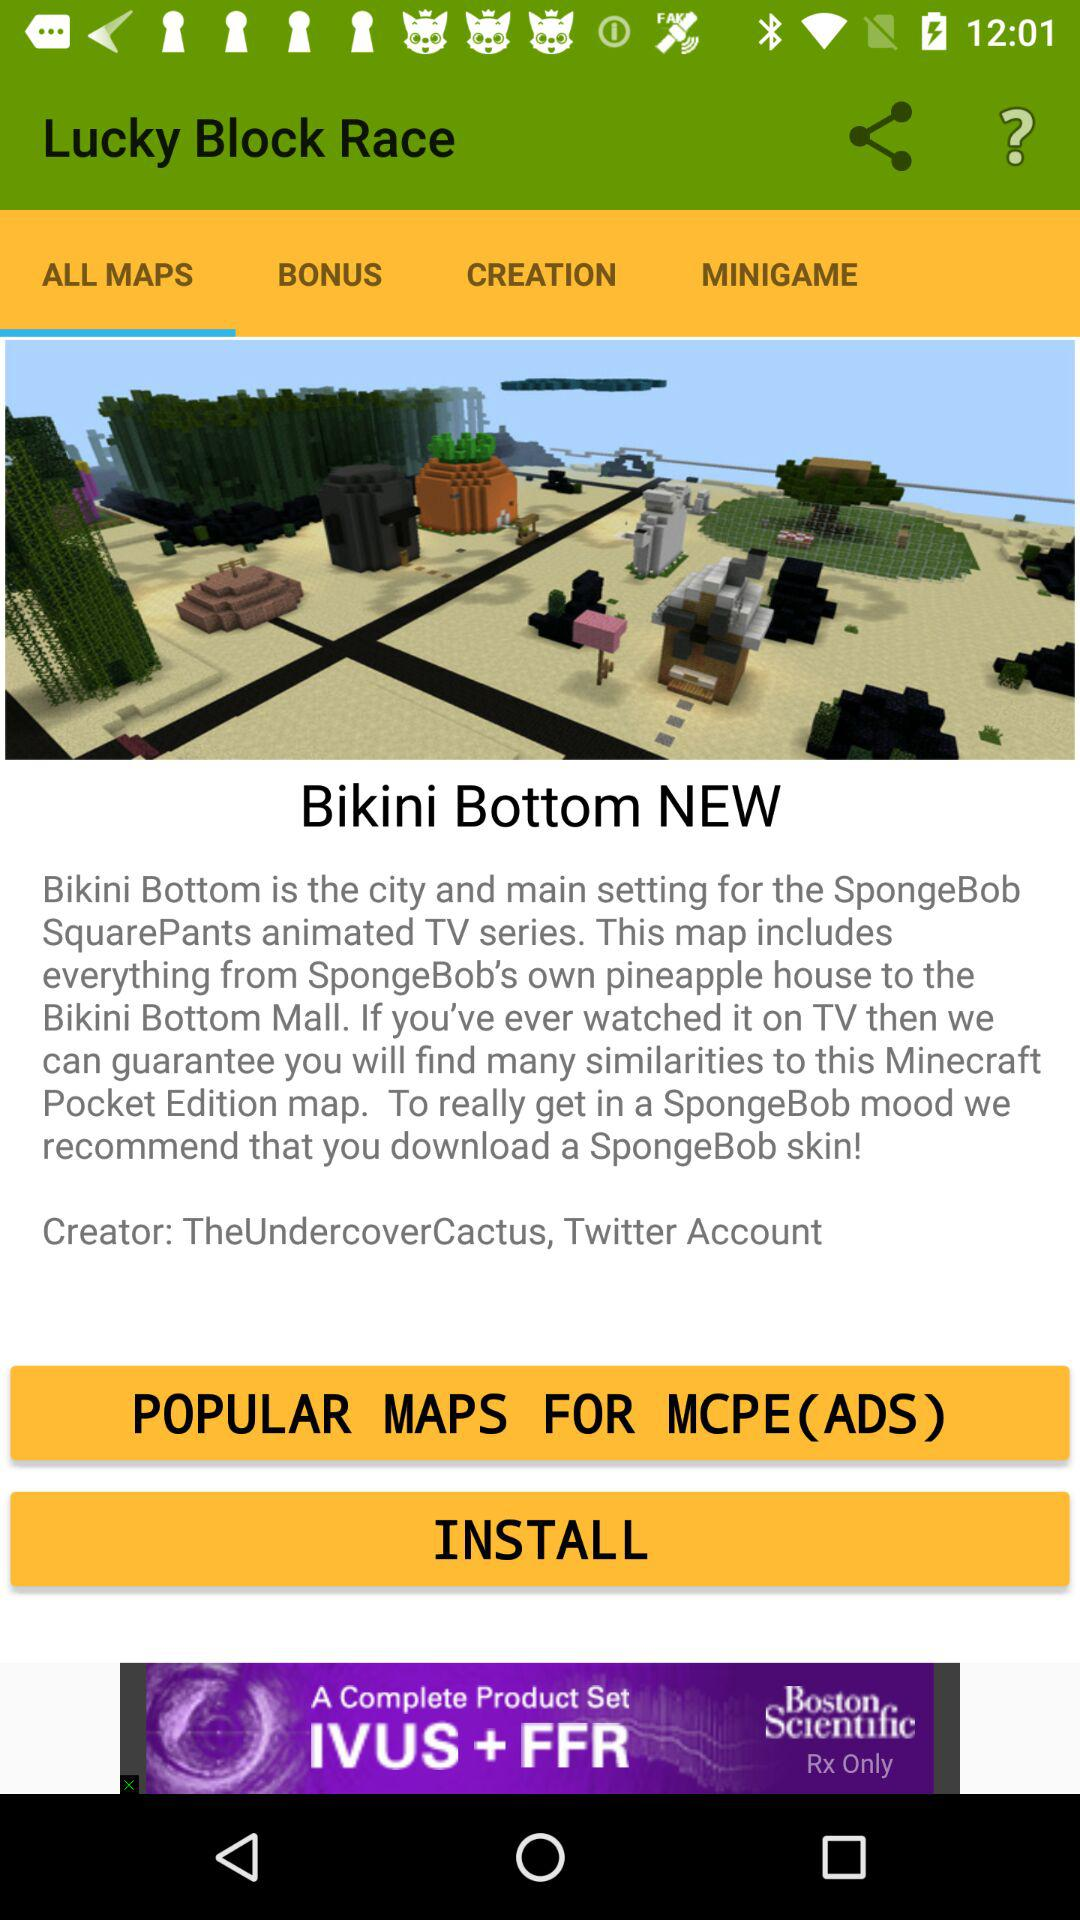What is the name of the application? The name of the application is "Lucky Block Race". 